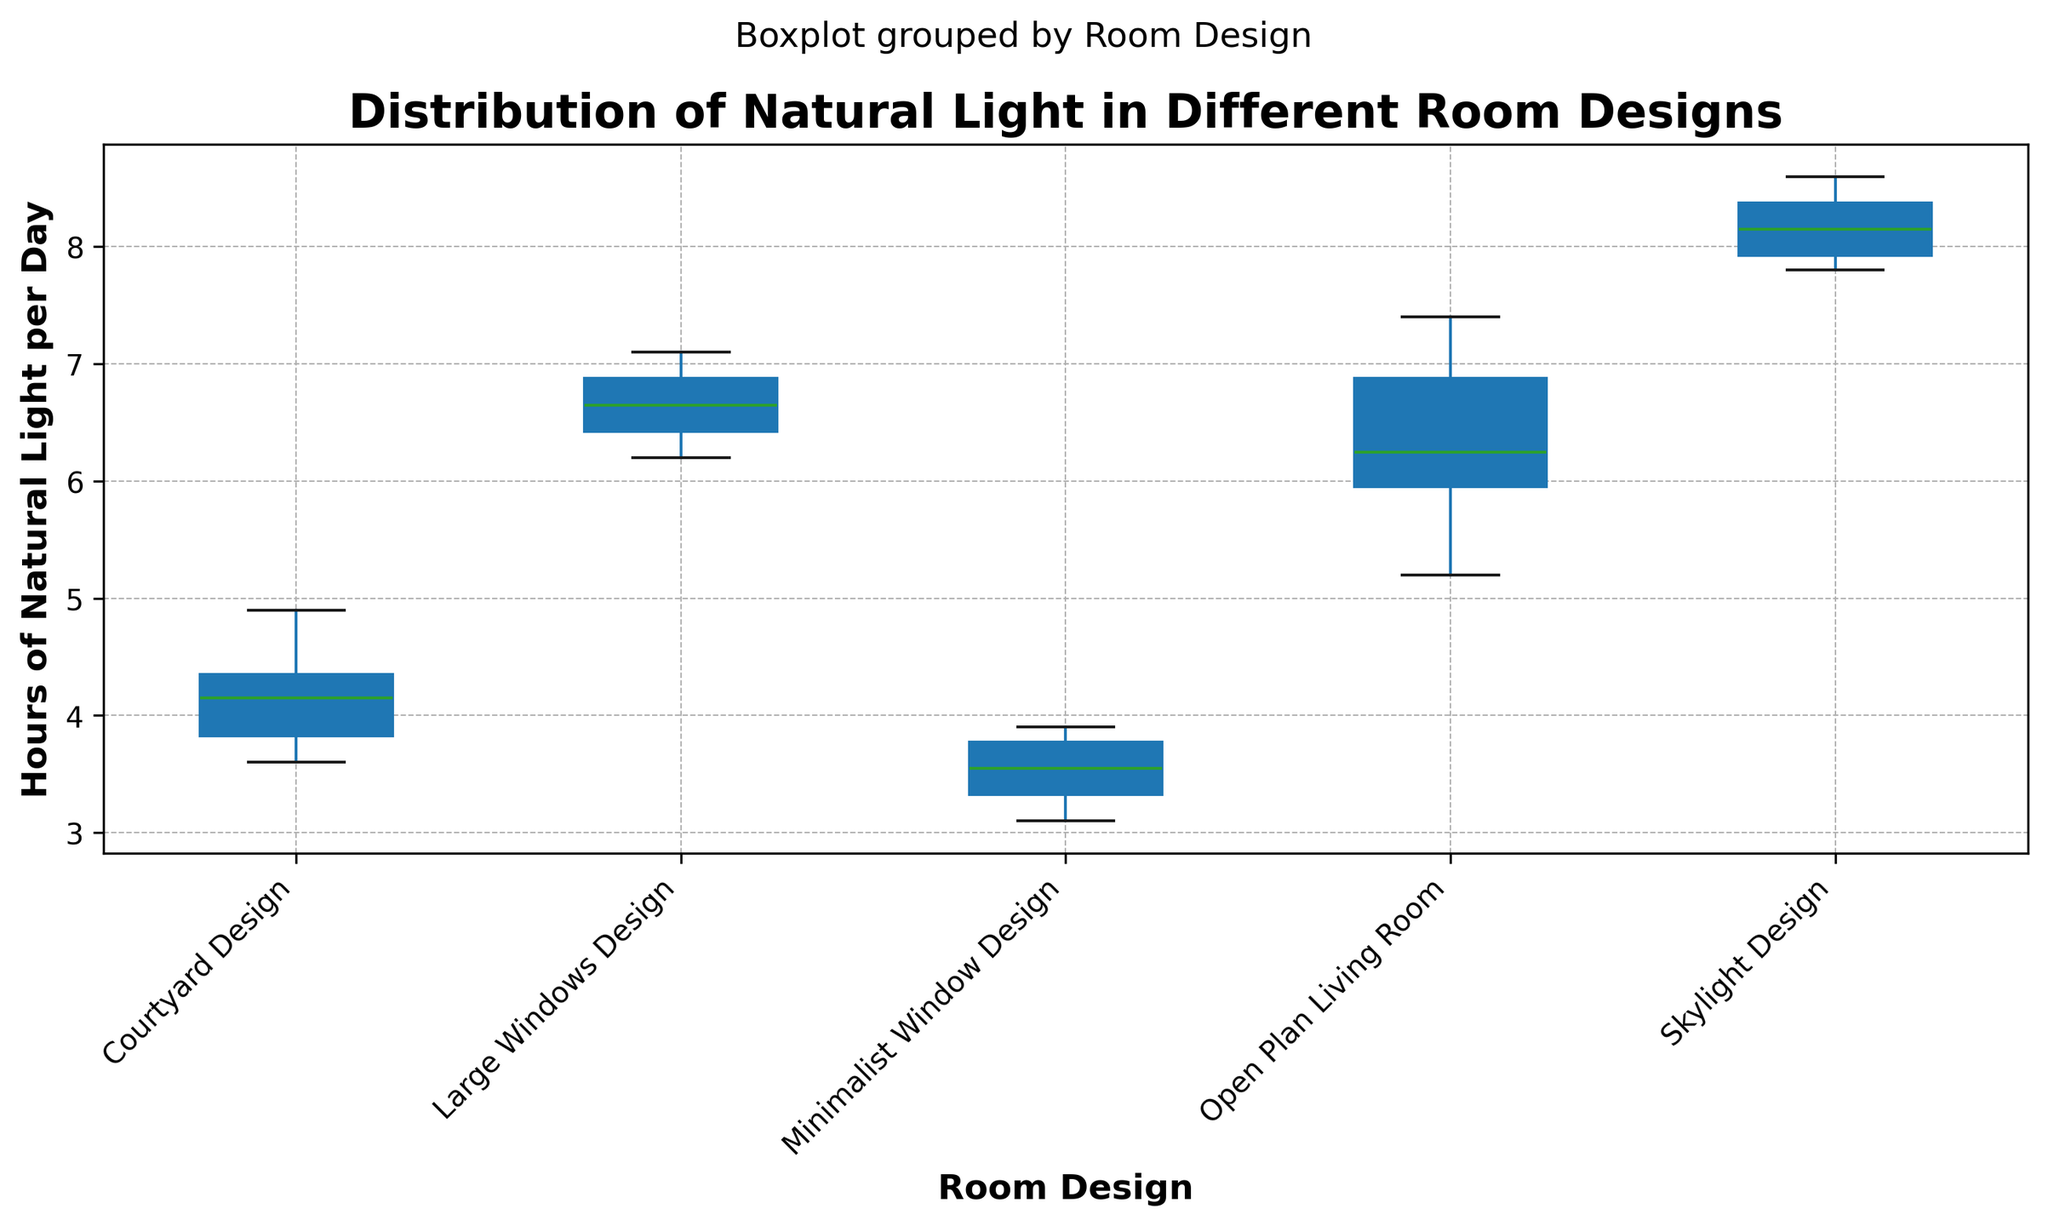What is the median value of hours of natural light per day for the Skylight Design? Locate the box plot for Skylight Design on the plot. The median value is represented by the line inside the box.
Answer: 8.1 Which room design receives the least amount of natural light on average? Observe all the room designs and compare their box plots' median values. The one with the lowest median value receives the least natural light on average.
Answer: Minimalist Window Design How does the variability in natural light compare between the Open Plan Living Room and the Courtyard Design? Look at the length of the boxes and the range of the whiskers in both room designs. The one with the longer box and whiskers has more variability.
Answer: The Open Plan Living Room has more variability Which room design has the highest interquartile range (IQR) for hours of natural light? The IQR is the length of the box in the box plot. Find the box plot with the largest box.
Answer: Open Plan Living Room Is the range of hours of natural light wider in the Skylight Design or the Minimalist Window Design? Compare the total length from the minimum whisker to the maximum whisker of both designs' box plots.
Answer: Skylight Design What is the maximum value of hours of natural light per day across all room designs? Identify the highest point (top whisker or outlier) across all box plots in the figure.
Answer: 8.6 Which room design has the smallest median value for hours of natural light? Look at all the box plots and identify the one with the lowest median line (inside the box).
Answer: Minimalist Window Design How do the medians of Large Windows Design and Open Plan Living Room compare? Find the median (line inside the box) of both designs and see which one is higher.
Answer: Large Windows Design is slightly higher Which room design has the smallest interquartile range (IQR) for hours of natural light? Find the box plot with the shortest box length.
Answer: Minimalist Window Design What's the difference between the maximum value of Skylight Design and the maximum value of Courtyard Design? Identify the maximum values (top whisker or outlier) of Skylight Design and Courtyard Design and subtract the Courtyard Design's value from the Skylight Design's value.
Answer: 4.8 